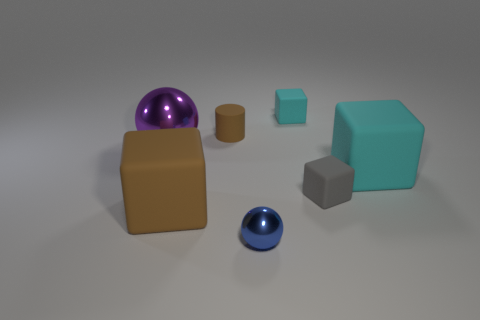What number of other objects are there of the same shape as the purple object?
Provide a succinct answer. 1. Is there any other thing that is the same size as the blue shiny sphere?
Keep it short and to the point. Yes. What material is the big purple object that is the same shape as the small blue thing?
Make the answer very short. Metal. Is there a big brown rubber block that is in front of the large rubber block that is in front of the small matte object that is in front of the cylinder?
Provide a short and direct response. No. There is a cyan matte object behind the big purple thing; is its shape the same as the big matte object behind the gray block?
Ensure brevity in your answer.  Yes. Are there more matte cubes in front of the brown block than large shiny objects?
Your response must be concise. No. What number of objects are either brown cylinders or tiny red cubes?
Provide a succinct answer. 1. What is the color of the small matte cylinder?
Your response must be concise. Brown. What number of other things are there of the same color as the large metal sphere?
Provide a short and direct response. 0. There is a blue sphere; are there any metal objects to the left of it?
Your response must be concise. Yes. 